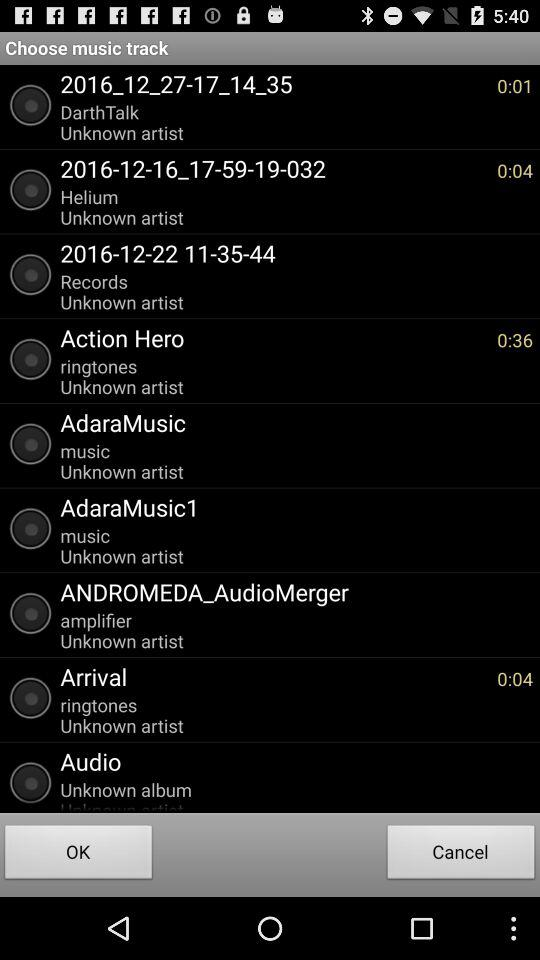How long is the "Arrival" music track? The "Arrival" music track is 4 seconds long. 